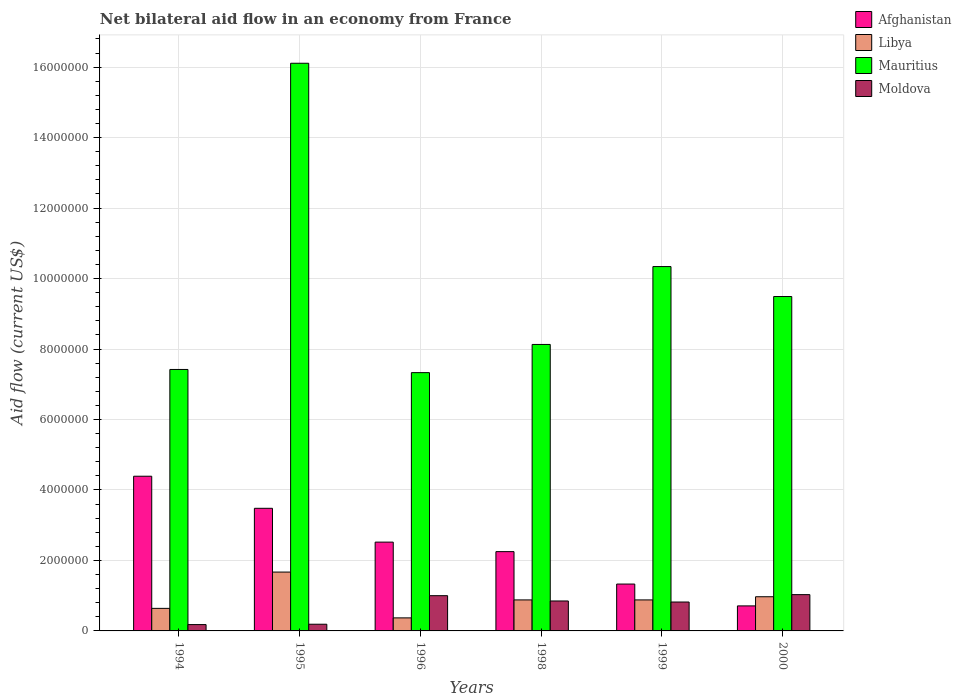How many different coloured bars are there?
Ensure brevity in your answer.  4. Are the number of bars per tick equal to the number of legend labels?
Offer a terse response. Yes. How many bars are there on the 4th tick from the left?
Your response must be concise. 4. How many bars are there on the 6th tick from the right?
Ensure brevity in your answer.  4. What is the label of the 5th group of bars from the left?
Your answer should be very brief. 1999. What is the net bilateral aid flow in Libya in 1999?
Offer a terse response. 8.80e+05. Across all years, what is the maximum net bilateral aid flow in Libya?
Your response must be concise. 1.67e+06. Across all years, what is the minimum net bilateral aid flow in Afghanistan?
Your answer should be compact. 7.10e+05. In which year was the net bilateral aid flow in Libya maximum?
Ensure brevity in your answer.  1995. What is the total net bilateral aid flow in Afghanistan in the graph?
Make the answer very short. 1.47e+07. What is the difference between the net bilateral aid flow in Libya in 1999 and that in 2000?
Provide a short and direct response. -9.00e+04. What is the difference between the net bilateral aid flow in Libya in 1999 and the net bilateral aid flow in Afghanistan in 1994?
Your response must be concise. -3.51e+06. What is the average net bilateral aid flow in Afghanistan per year?
Your response must be concise. 2.45e+06. In the year 1994, what is the difference between the net bilateral aid flow in Mauritius and net bilateral aid flow in Moldova?
Ensure brevity in your answer.  7.24e+06. What is the ratio of the net bilateral aid flow in Afghanistan in 1995 to that in 1998?
Your answer should be compact. 1.55. What is the difference between the highest and the lowest net bilateral aid flow in Moldova?
Provide a short and direct response. 8.50e+05. Is the sum of the net bilateral aid flow in Moldova in 1995 and 1998 greater than the maximum net bilateral aid flow in Mauritius across all years?
Your response must be concise. No. Is it the case that in every year, the sum of the net bilateral aid flow in Libya and net bilateral aid flow in Mauritius is greater than the sum of net bilateral aid flow in Moldova and net bilateral aid flow in Afghanistan?
Offer a very short reply. Yes. What does the 1st bar from the left in 1995 represents?
Make the answer very short. Afghanistan. What does the 4th bar from the right in 1996 represents?
Offer a terse response. Afghanistan. Are all the bars in the graph horizontal?
Offer a very short reply. No. How many years are there in the graph?
Give a very brief answer. 6. What is the difference between two consecutive major ticks on the Y-axis?
Provide a short and direct response. 2.00e+06. Are the values on the major ticks of Y-axis written in scientific E-notation?
Your answer should be compact. No. Does the graph contain any zero values?
Keep it short and to the point. No. Does the graph contain grids?
Your answer should be compact. Yes. Where does the legend appear in the graph?
Offer a terse response. Top right. How are the legend labels stacked?
Provide a short and direct response. Vertical. What is the title of the graph?
Keep it short and to the point. Net bilateral aid flow in an economy from France. What is the Aid flow (current US$) of Afghanistan in 1994?
Make the answer very short. 4.39e+06. What is the Aid flow (current US$) in Libya in 1994?
Your answer should be compact. 6.40e+05. What is the Aid flow (current US$) of Mauritius in 1994?
Your response must be concise. 7.42e+06. What is the Aid flow (current US$) in Moldova in 1994?
Provide a short and direct response. 1.80e+05. What is the Aid flow (current US$) in Afghanistan in 1995?
Your answer should be very brief. 3.48e+06. What is the Aid flow (current US$) in Libya in 1995?
Your response must be concise. 1.67e+06. What is the Aid flow (current US$) in Mauritius in 1995?
Your response must be concise. 1.61e+07. What is the Aid flow (current US$) of Moldova in 1995?
Ensure brevity in your answer.  1.90e+05. What is the Aid flow (current US$) of Afghanistan in 1996?
Give a very brief answer. 2.52e+06. What is the Aid flow (current US$) in Libya in 1996?
Give a very brief answer. 3.70e+05. What is the Aid flow (current US$) in Mauritius in 1996?
Ensure brevity in your answer.  7.33e+06. What is the Aid flow (current US$) in Afghanistan in 1998?
Provide a succinct answer. 2.25e+06. What is the Aid flow (current US$) in Libya in 1998?
Your answer should be very brief. 8.80e+05. What is the Aid flow (current US$) in Mauritius in 1998?
Your response must be concise. 8.13e+06. What is the Aid flow (current US$) of Moldova in 1998?
Give a very brief answer. 8.50e+05. What is the Aid flow (current US$) of Afghanistan in 1999?
Keep it short and to the point. 1.33e+06. What is the Aid flow (current US$) in Libya in 1999?
Your answer should be compact. 8.80e+05. What is the Aid flow (current US$) of Mauritius in 1999?
Offer a very short reply. 1.03e+07. What is the Aid flow (current US$) in Moldova in 1999?
Provide a short and direct response. 8.20e+05. What is the Aid flow (current US$) of Afghanistan in 2000?
Keep it short and to the point. 7.10e+05. What is the Aid flow (current US$) in Libya in 2000?
Ensure brevity in your answer.  9.70e+05. What is the Aid flow (current US$) of Mauritius in 2000?
Offer a terse response. 9.49e+06. What is the Aid flow (current US$) of Moldova in 2000?
Your response must be concise. 1.03e+06. Across all years, what is the maximum Aid flow (current US$) in Afghanistan?
Keep it short and to the point. 4.39e+06. Across all years, what is the maximum Aid flow (current US$) in Libya?
Your answer should be very brief. 1.67e+06. Across all years, what is the maximum Aid flow (current US$) of Mauritius?
Your response must be concise. 1.61e+07. Across all years, what is the maximum Aid flow (current US$) of Moldova?
Provide a short and direct response. 1.03e+06. Across all years, what is the minimum Aid flow (current US$) of Afghanistan?
Provide a short and direct response. 7.10e+05. Across all years, what is the minimum Aid flow (current US$) in Mauritius?
Give a very brief answer. 7.33e+06. Across all years, what is the minimum Aid flow (current US$) of Moldova?
Provide a succinct answer. 1.80e+05. What is the total Aid flow (current US$) of Afghanistan in the graph?
Keep it short and to the point. 1.47e+07. What is the total Aid flow (current US$) in Libya in the graph?
Give a very brief answer. 5.41e+06. What is the total Aid flow (current US$) in Mauritius in the graph?
Your answer should be very brief. 5.88e+07. What is the total Aid flow (current US$) in Moldova in the graph?
Your answer should be very brief. 4.07e+06. What is the difference between the Aid flow (current US$) in Afghanistan in 1994 and that in 1995?
Provide a succinct answer. 9.10e+05. What is the difference between the Aid flow (current US$) of Libya in 1994 and that in 1995?
Make the answer very short. -1.03e+06. What is the difference between the Aid flow (current US$) in Mauritius in 1994 and that in 1995?
Your answer should be very brief. -8.69e+06. What is the difference between the Aid flow (current US$) in Afghanistan in 1994 and that in 1996?
Offer a terse response. 1.87e+06. What is the difference between the Aid flow (current US$) of Libya in 1994 and that in 1996?
Provide a succinct answer. 2.70e+05. What is the difference between the Aid flow (current US$) in Moldova in 1994 and that in 1996?
Ensure brevity in your answer.  -8.20e+05. What is the difference between the Aid flow (current US$) in Afghanistan in 1994 and that in 1998?
Your answer should be very brief. 2.14e+06. What is the difference between the Aid flow (current US$) in Libya in 1994 and that in 1998?
Make the answer very short. -2.40e+05. What is the difference between the Aid flow (current US$) in Mauritius in 1994 and that in 1998?
Give a very brief answer. -7.10e+05. What is the difference between the Aid flow (current US$) of Moldova in 1994 and that in 1998?
Provide a short and direct response. -6.70e+05. What is the difference between the Aid flow (current US$) in Afghanistan in 1994 and that in 1999?
Your answer should be compact. 3.06e+06. What is the difference between the Aid flow (current US$) in Libya in 1994 and that in 1999?
Your answer should be very brief. -2.40e+05. What is the difference between the Aid flow (current US$) of Mauritius in 1994 and that in 1999?
Provide a short and direct response. -2.92e+06. What is the difference between the Aid flow (current US$) in Moldova in 1994 and that in 1999?
Provide a short and direct response. -6.40e+05. What is the difference between the Aid flow (current US$) in Afghanistan in 1994 and that in 2000?
Offer a very short reply. 3.68e+06. What is the difference between the Aid flow (current US$) of Libya in 1994 and that in 2000?
Your response must be concise. -3.30e+05. What is the difference between the Aid flow (current US$) in Mauritius in 1994 and that in 2000?
Your response must be concise. -2.07e+06. What is the difference between the Aid flow (current US$) in Moldova in 1994 and that in 2000?
Offer a terse response. -8.50e+05. What is the difference between the Aid flow (current US$) in Afghanistan in 1995 and that in 1996?
Your answer should be compact. 9.60e+05. What is the difference between the Aid flow (current US$) in Libya in 1995 and that in 1996?
Make the answer very short. 1.30e+06. What is the difference between the Aid flow (current US$) in Mauritius in 1995 and that in 1996?
Provide a succinct answer. 8.78e+06. What is the difference between the Aid flow (current US$) of Moldova in 1995 and that in 1996?
Keep it short and to the point. -8.10e+05. What is the difference between the Aid flow (current US$) of Afghanistan in 1995 and that in 1998?
Offer a very short reply. 1.23e+06. What is the difference between the Aid flow (current US$) in Libya in 1995 and that in 1998?
Make the answer very short. 7.90e+05. What is the difference between the Aid flow (current US$) of Mauritius in 1995 and that in 1998?
Provide a succinct answer. 7.98e+06. What is the difference between the Aid flow (current US$) of Moldova in 1995 and that in 1998?
Offer a very short reply. -6.60e+05. What is the difference between the Aid flow (current US$) in Afghanistan in 1995 and that in 1999?
Keep it short and to the point. 2.15e+06. What is the difference between the Aid flow (current US$) of Libya in 1995 and that in 1999?
Offer a very short reply. 7.90e+05. What is the difference between the Aid flow (current US$) of Mauritius in 1995 and that in 1999?
Keep it short and to the point. 5.77e+06. What is the difference between the Aid flow (current US$) of Moldova in 1995 and that in 1999?
Keep it short and to the point. -6.30e+05. What is the difference between the Aid flow (current US$) in Afghanistan in 1995 and that in 2000?
Offer a very short reply. 2.77e+06. What is the difference between the Aid flow (current US$) of Libya in 1995 and that in 2000?
Keep it short and to the point. 7.00e+05. What is the difference between the Aid flow (current US$) of Mauritius in 1995 and that in 2000?
Your answer should be compact. 6.62e+06. What is the difference between the Aid flow (current US$) in Moldova in 1995 and that in 2000?
Make the answer very short. -8.40e+05. What is the difference between the Aid flow (current US$) of Afghanistan in 1996 and that in 1998?
Keep it short and to the point. 2.70e+05. What is the difference between the Aid flow (current US$) in Libya in 1996 and that in 1998?
Your response must be concise. -5.10e+05. What is the difference between the Aid flow (current US$) of Mauritius in 1996 and that in 1998?
Keep it short and to the point. -8.00e+05. What is the difference between the Aid flow (current US$) in Moldova in 1996 and that in 1998?
Your response must be concise. 1.50e+05. What is the difference between the Aid flow (current US$) in Afghanistan in 1996 and that in 1999?
Give a very brief answer. 1.19e+06. What is the difference between the Aid flow (current US$) in Libya in 1996 and that in 1999?
Provide a short and direct response. -5.10e+05. What is the difference between the Aid flow (current US$) of Mauritius in 1996 and that in 1999?
Your response must be concise. -3.01e+06. What is the difference between the Aid flow (current US$) of Afghanistan in 1996 and that in 2000?
Provide a succinct answer. 1.81e+06. What is the difference between the Aid flow (current US$) in Libya in 1996 and that in 2000?
Your response must be concise. -6.00e+05. What is the difference between the Aid flow (current US$) in Mauritius in 1996 and that in 2000?
Offer a terse response. -2.16e+06. What is the difference between the Aid flow (current US$) in Moldova in 1996 and that in 2000?
Give a very brief answer. -3.00e+04. What is the difference between the Aid flow (current US$) in Afghanistan in 1998 and that in 1999?
Your answer should be very brief. 9.20e+05. What is the difference between the Aid flow (current US$) of Mauritius in 1998 and that in 1999?
Offer a terse response. -2.21e+06. What is the difference between the Aid flow (current US$) of Afghanistan in 1998 and that in 2000?
Make the answer very short. 1.54e+06. What is the difference between the Aid flow (current US$) of Libya in 1998 and that in 2000?
Keep it short and to the point. -9.00e+04. What is the difference between the Aid flow (current US$) in Mauritius in 1998 and that in 2000?
Make the answer very short. -1.36e+06. What is the difference between the Aid flow (current US$) of Moldova in 1998 and that in 2000?
Your answer should be compact. -1.80e+05. What is the difference between the Aid flow (current US$) of Afghanistan in 1999 and that in 2000?
Provide a succinct answer. 6.20e+05. What is the difference between the Aid flow (current US$) of Libya in 1999 and that in 2000?
Your response must be concise. -9.00e+04. What is the difference between the Aid flow (current US$) in Mauritius in 1999 and that in 2000?
Your answer should be very brief. 8.50e+05. What is the difference between the Aid flow (current US$) in Afghanistan in 1994 and the Aid flow (current US$) in Libya in 1995?
Your answer should be compact. 2.72e+06. What is the difference between the Aid flow (current US$) in Afghanistan in 1994 and the Aid flow (current US$) in Mauritius in 1995?
Provide a short and direct response. -1.17e+07. What is the difference between the Aid flow (current US$) of Afghanistan in 1994 and the Aid flow (current US$) of Moldova in 1995?
Keep it short and to the point. 4.20e+06. What is the difference between the Aid flow (current US$) in Libya in 1994 and the Aid flow (current US$) in Mauritius in 1995?
Your response must be concise. -1.55e+07. What is the difference between the Aid flow (current US$) of Libya in 1994 and the Aid flow (current US$) of Moldova in 1995?
Your response must be concise. 4.50e+05. What is the difference between the Aid flow (current US$) in Mauritius in 1994 and the Aid flow (current US$) in Moldova in 1995?
Keep it short and to the point. 7.23e+06. What is the difference between the Aid flow (current US$) in Afghanistan in 1994 and the Aid flow (current US$) in Libya in 1996?
Make the answer very short. 4.02e+06. What is the difference between the Aid flow (current US$) in Afghanistan in 1994 and the Aid flow (current US$) in Mauritius in 1996?
Ensure brevity in your answer.  -2.94e+06. What is the difference between the Aid flow (current US$) of Afghanistan in 1994 and the Aid flow (current US$) of Moldova in 1996?
Provide a succinct answer. 3.39e+06. What is the difference between the Aid flow (current US$) in Libya in 1994 and the Aid flow (current US$) in Mauritius in 1996?
Ensure brevity in your answer.  -6.69e+06. What is the difference between the Aid flow (current US$) in Libya in 1994 and the Aid flow (current US$) in Moldova in 1996?
Your answer should be very brief. -3.60e+05. What is the difference between the Aid flow (current US$) of Mauritius in 1994 and the Aid flow (current US$) of Moldova in 1996?
Provide a short and direct response. 6.42e+06. What is the difference between the Aid flow (current US$) in Afghanistan in 1994 and the Aid flow (current US$) in Libya in 1998?
Offer a terse response. 3.51e+06. What is the difference between the Aid flow (current US$) in Afghanistan in 1994 and the Aid flow (current US$) in Mauritius in 1998?
Provide a succinct answer. -3.74e+06. What is the difference between the Aid flow (current US$) in Afghanistan in 1994 and the Aid flow (current US$) in Moldova in 1998?
Offer a terse response. 3.54e+06. What is the difference between the Aid flow (current US$) in Libya in 1994 and the Aid flow (current US$) in Mauritius in 1998?
Your answer should be very brief. -7.49e+06. What is the difference between the Aid flow (current US$) of Libya in 1994 and the Aid flow (current US$) of Moldova in 1998?
Provide a succinct answer. -2.10e+05. What is the difference between the Aid flow (current US$) of Mauritius in 1994 and the Aid flow (current US$) of Moldova in 1998?
Provide a succinct answer. 6.57e+06. What is the difference between the Aid flow (current US$) of Afghanistan in 1994 and the Aid flow (current US$) of Libya in 1999?
Your answer should be compact. 3.51e+06. What is the difference between the Aid flow (current US$) in Afghanistan in 1994 and the Aid flow (current US$) in Mauritius in 1999?
Offer a terse response. -5.95e+06. What is the difference between the Aid flow (current US$) of Afghanistan in 1994 and the Aid flow (current US$) of Moldova in 1999?
Give a very brief answer. 3.57e+06. What is the difference between the Aid flow (current US$) in Libya in 1994 and the Aid flow (current US$) in Mauritius in 1999?
Your response must be concise. -9.70e+06. What is the difference between the Aid flow (current US$) of Libya in 1994 and the Aid flow (current US$) of Moldova in 1999?
Give a very brief answer. -1.80e+05. What is the difference between the Aid flow (current US$) of Mauritius in 1994 and the Aid flow (current US$) of Moldova in 1999?
Offer a terse response. 6.60e+06. What is the difference between the Aid flow (current US$) of Afghanistan in 1994 and the Aid flow (current US$) of Libya in 2000?
Your answer should be very brief. 3.42e+06. What is the difference between the Aid flow (current US$) in Afghanistan in 1994 and the Aid flow (current US$) in Mauritius in 2000?
Keep it short and to the point. -5.10e+06. What is the difference between the Aid flow (current US$) in Afghanistan in 1994 and the Aid flow (current US$) in Moldova in 2000?
Offer a very short reply. 3.36e+06. What is the difference between the Aid flow (current US$) of Libya in 1994 and the Aid flow (current US$) of Mauritius in 2000?
Your answer should be very brief. -8.85e+06. What is the difference between the Aid flow (current US$) in Libya in 1994 and the Aid flow (current US$) in Moldova in 2000?
Provide a succinct answer. -3.90e+05. What is the difference between the Aid flow (current US$) in Mauritius in 1994 and the Aid flow (current US$) in Moldova in 2000?
Provide a short and direct response. 6.39e+06. What is the difference between the Aid flow (current US$) in Afghanistan in 1995 and the Aid flow (current US$) in Libya in 1996?
Offer a very short reply. 3.11e+06. What is the difference between the Aid flow (current US$) of Afghanistan in 1995 and the Aid flow (current US$) of Mauritius in 1996?
Ensure brevity in your answer.  -3.85e+06. What is the difference between the Aid flow (current US$) in Afghanistan in 1995 and the Aid flow (current US$) in Moldova in 1996?
Offer a very short reply. 2.48e+06. What is the difference between the Aid flow (current US$) of Libya in 1995 and the Aid flow (current US$) of Mauritius in 1996?
Offer a terse response. -5.66e+06. What is the difference between the Aid flow (current US$) in Libya in 1995 and the Aid flow (current US$) in Moldova in 1996?
Keep it short and to the point. 6.70e+05. What is the difference between the Aid flow (current US$) of Mauritius in 1995 and the Aid flow (current US$) of Moldova in 1996?
Keep it short and to the point. 1.51e+07. What is the difference between the Aid flow (current US$) in Afghanistan in 1995 and the Aid flow (current US$) in Libya in 1998?
Offer a very short reply. 2.60e+06. What is the difference between the Aid flow (current US$) of Afghanistan in 1995 and the Aid flow (current US$) of Mauritius in 1998?
Your answer should be very brief. -4.65e+06. What is the difference between the Aid flow (current US$) in Afghanistan in 1995 and the Aid flow (current US$) in Moldova in 1998?
Give a very brief answer. 2.63e+06. What is the difference between the Aid flow (current US$) in Libya in 1995 and the Aid flow (current US$) in Mauritius in 1998?
Provide a succinct answer. -6.46e+06. What is the difference between the Aid flow (current US$) in Libya in 1995 and the Aid flow (current US$) in Moldova in 1998?
Provide a succinct answer. 8.20e+05. What is the difference between the Aid flow (current US$) of Mauritius in 1995 and the Aid flow (current US$) of Moldova in 1998?
Your response must be concise. 1.53e+07. What is the difference between the Aid flow (current US$) of Afghanistan in 1995 and the Aid flow (current US$) of Libya in 1999?
Make the answer very short. 2.60e+06. What is the difference between the Aid flow (current US$) in Afghanistan in 1995 and the Aid flow (current US$) in Mauritius in 1999?
Give a very brief answer. -6.86e+06. What is the difference between the Aid flow (current US$) in Afghanistan in 1995 and the Aid flow (current US$) in Moldova in 1999?
Offer a very short reply. 2.66e+06. What is the difference between the Aid flow (current US$) in Libya in 1995 and the Aid flow (current US$) in Mauritius in 1999?
Your answer should be very brief. -8.67e+06. What is the difference between the Aid flow (current US$) of Libya in 1995 and the Aid flow (current US$) of Moldova in 1999?
Your response must be concise. 8.50e+05. What is the difference between the Aid flow (current US$) of Mauritius in 1995 and the Aid flow (current US$) of Moldova in 1999?
Keep it short and to the point. 1.53e+07. What is the difference between the Aid flow (current US$) of Afghanistan in 1995 and the Aid flow (current US$) of Libya in 2000?
Offer a terse response. 2.51e+06. What is the difference between the Aid flow (current US$) of Afghanistan in 1995 and the Aid flow (current US$) of Mauritius in 2000?
Offer a terse response. -6.01e+06. What is the difference between the Aid flow (current US$) of Afghanistan in 1995 and the Aid flow (current US$) of Moldova in 2000?
Provide a short and direct response. 2.45e+06. What is the difference between the Aid flow (current US$) in Libya in 1995 and the Aid flow (current US$) in Mauritius in 2000?
Ensure brevity in your answer.  -7.82e+06. What is the difference between the Aid flow (current US$) of Libya in 1995 and the Aid flow (current US$) of Moldova in 2000?
Offer a very short reply. 6.40e+05. What is the difference between the Aid flow (current US$) of Mauritius in 1995 and the Aid flow (current US$) of Moldova in 2000?
Give a very brief answer. 1.51e+07. What is the difference between the Aid flow (current US$) in Afghanistan in 1996 and the Aid flow (current US$) in Libya in 1998?
Your answer should be very brief. 1.64e+06. What is the difference between the Aid flow (current US$) of Afghanistan in 1996 and the Aid flow (current US$) of Mauritius in 1998?
Keep it short and to the point. -5.61e+06. What is the difference between the Aid flow (current US$) of Afghanistan in 1996 and the Aid flow (current US$) of Moldova in 1998?
Ensure brevity in your answer.  1.67e+06. What is the difference between the Aid flow (current US$) of Libya in 1996 and the Aid flow (current US$) of Mauritius in 1998?
Ensure brevity in your answer.  -7.76e+06. What is the difference between the Aid flow (current US$) in Libya in 1996 and the Aid flow (current US$) in Moldova in 1998?
Offer a terse response. -4.80e+05. What is the difference between the Aid flow (current US$) of Mauritius in 1996 and the Aid flow (current US$) of Moldova in 1998?
Offer a terse response. 6.48e+06. What is the difference between the Aid flow (current US$) in Afghanistan in 1996 and the Aid flow (current US$) in Libya in 1999?
Offer a very short reply. 1.64e+06. What is the difference between the Aid flow (current US$) in Afghanistan in 1996 and the Aid flow (current US$) in Mauritius in 1999?
Make the answer very short. -7.82e+06. What is the difference between the Aid flow (current US$) in Afghanistan in 1996 and the Aid flow (current US$) in Moldova in 1999?
Ensure brevity in your answer.  1.70e+06. What is the difference between the Aid flow (current US$) of Libya in 1996 and the Aid flow (current US$) of Mauritius in 1999?
Keep it short and to the point. -9.97e+06. What is the difference between the Aid flow (current US$) in Libya in 1996 and the Aid flow (current US$) in Moldova in 1999?
Ensure brevity in your answer.  -4.50e+05. What is the difference between the Aid flow (current US$) of Mauritius in 1996 and the Aid flow (current US$) of Moldova in 1999?
Keep it short and to the point. 6.51e+06. What is the difference between the Aid flow (current US$) in Afghanistan in 1996 and the Aid flow (current US$) in Libya in 2000?
Ensure brevity in your answer.  1.55e+06. What is the difference between the Aid flow (current US$) of Afghanistan in 1996 and the Aid flow (current US$) of Mauritius in 2000?
Offer a terse response. -6.97e+06. What is the difference between the Aid flow (current US$) of Afghanistan in 1996 and the Aid flow (current US$) of Moldova in 2000?
Provide a succinct answer. 1.49e+06. What is the difference between the Aid flow (current US$) of Libya in 1996 and the Aid flow (current US$) of Mauritius in 2000?
Provide a succinct answer. -9.12e+06. What is the difference between the Aid flow (current US$) in Libya in 1996 and the Aid flow (current US$) in Moldova in 2000?
Keep it short and to the point. -6.60e+05. What is the difference between the Aid flow (current US$) of Mauritius in 1996 and the Aid flow (current US$) of Moldova in 2000?
Provide a short and direct response. 6.30e+06. What is the difference between the Aid flow (current US$) in Afghanistan in 1998 and the Aid flow (current US$) in Libya in 1999?
Your answer should be very brief. 1.37e+06. What is the difference between the Aid flow (current US$) of Afghanistan in 1998 and the Aid flow (current US$) of Mauritius in 1999?
Offer a very short reply. -8.09e+06. What is the difference between the Aid flow (current US$) of Afghanistan in 1998 and the Aid flow (current US$) of Moldova in 1999?
Provide a short and direct response. 1.43e+06. What is the difference between the Aid flow (current US$) in Libya in 1998 and the Aid flow (current US$) in Mauritius in 1999?
Provide a short and direct response. -9.46e+06. What is the difference between the Aid flow (current US$) of Libya in 1998 and the Aid flow (current US$) of Moldova in 1999?
Make the answer very short. 6.00e+04. What is the difference between the Aid flow (current US$) in Mauritius in 1998 and the Aid flow (current US$) in Moldova in 1999?
Your response must be concise. 7.31e+06. What is the difference between the Aid flow (current US$) of Afghanistan in 1998 and the Aid flow (current US$) of Libya in 2000?
Ensure brevity in your answer.  1.28e+06. What is the difference between the Aid flow (current US$) in Afghanistan in 1998 and the Aid flow (current US$) in Mauritius in 2000?
Offer a terse response. -7.24e+06. What is the difference between the Aid flow (current US$) in Afghanistan in 1998 and the Aid flow (current US$) in Moldova in 2000?
Provide a short and direct response. 1.22e+06. What is the difference between the Aid flow (current US$) of Libya in 1998 and the Aid flow (current US$) of Mauritius in 2000?
Give a very brief answer. -8.61e+06. What is the difference between the Aid flow (current US$) in Libya in 1998 and the Aid flow (current US$) in Moldova in 2000?
Provide a short and direct response. -1.50e+05. What is the difference between the Aid flow (current US$) of Mauritius in 1998 and the Aid flow (current US$) of Moldova in 2000?
Give a very brief answer. 7.10e+06. What is the difference between the Aid flow (current US$) in Afghanistan in 1999 and the Aid flow (current US$) in Mauritius in 2000?
Keep it short and to the point. -8.16e+06. What is the difference between the Aid flow (current US$) of Afghanistan in 1999 and the Aid flow (current US$) of Moldova in 2000?
Keep it short and to the point. 3.00e+05. What is the difference between the Aid flow (current US$) in Libya in 1999 and the Aid flow (current US$) in Mauritius in 2000?
Your answer should be compact. -8.61e+06. What is the difference between the Aid flow (current US$) of Mauritius in 1999 and the Aid flow (current US$) of Moldova in 2000?
Provide a succinct answer. 9.31e+06. What is the average Aid flow (current US$) of Afghanistan per year?
Your answer should be compact. 2.45e+06. What is the average Aid flow (current US$) in Libya per year?
Your answer should be very brief. 9.02e+05. What is the average Aid flow (current US$) of Mauritius per year?
Offer a very short reply. 9.80e+06. What is the average Aid flow (current US$) in Moldova per year?
Keep it short and to the point. 6.78e+05. In the year 1994, what is the difference between the Aid flow (current US$) in Afghanistan and Aid flow (current US$) in Libya?
Provide a succinct answer. 3.75e+06. In the year 1994, what is the difference between the Aid flow (current US$) of Afghanistan and Aid flow (current US$) of Mauritius?
Your response must be concise. -3.03e+06. In the year 1994, what is the difference between the Aid flow (current US$) in Afghanistan and Aid flow (current US$) in Moldova?
Provide a succinct answer. 4.21e+06. In the year 1994, what is the difference between the Aid flow (current US$) of Libya and Aid flow (current US$) of Mauritius?
Provide a succinct answer. -6.78e+06. In the year 1994, what is the difference between the Aid flow (current US$) in Libya and Aid flow (current US$) in Moldova?
Your answer should be very brief. 4.60e+05. In the year 1994, what is the difference between the Aid flow (current US$) of Mauritius and Aid flow (current US$) of Moldova?
Make the answer very short. 7.24e+06. In the year 1995, what is the difference between the Aid flow (current US$) of Afghanistan and Aid flow (current US$) of Libya?
Your answer should be compact. 1.81e+06. In the year 1995, what is the difference between the Aid flow (current US$) in Afghanistan and Aid flow (current US$) in Mauritius?
Offer a terse response. -1.26e+07. In the year 1995, what is the difference between the Aid flow (current US$) in Afghanistan and Aid flow (current US$) in Moldova?
Offer a very short reply. 3.29e+06. In the year 1995, what is the difference between the Aid flow (current US$) in Libya and Aid flow (current US$) in Mauritius?
Offer a very short reply. -1.44e+07. In the year 1995, what is the difference between the Aid flow (current US$) in Libya and Aid flow (current US$) in Moldova?
Offer a terse response. 1.48e+06. In the year 1995, what is the difference between the Aid flow (current US$) in Mauritius and Aid flow (current US$) in Moldova?
Offer a terse response. 1.59e+07. In the year 1996, what is the difference between the Aid flow (current US$) of Afghanistan and Aid flow (current US$) of Libya?
Give a very brief answer. 2.15e+06. In the year 1996, what is the difference between the Aid flow (current US$) in Afghanistan and Aid flow (current US$) in Mauritius?
Your answer should be very brief. -4.81e+06. In the year 1996, what is the difference between the Aid flow (current US$) in Afghanistan and Aid flow (current US$) in Moldova?
Make the answer very short. 1.52e+06. In the year 1996, what is the difference between the Aid flow (current US$) of Libya and Aid flow (current US$) of Mauritius?
Offer a very short reply. -6.96e+06. In the year 1996, what is the difference between the Aid flow (current US$) of Libya and Aid flow (current US$) of Moldova?
Offer a terse response. -6.30e+05. In the year 1996, what is the difference between the Aid flow (current US$) in Mauritius and Aid flow (current US$) in Moldova?
Your answer should be very brief. 6.33e+06. In the year 1998, what is the difference between the Aid flow (current US$) in Afghanistan and Aid flow (current US$) in Libya?
Your answer should be compact. 1.37e+06. In the year 1998, what is the difference between the Aid flow (current US$) in Afghanistan and Aid flow (current US$) in Mauritius?
Your response must be concise. -5.88e+06. In the year 1998, what is the difference between the Aid flow (current US$) in Afghanistan and Aid flow (current US$) in Moldova?
Your response must be concise. 1.40e+06. In the year 1998, what is the difference between the Aid flow (current US$) of Libya and Aid flow (current US$) of Mauritius?
Ensure brevity in your answer.  -7.25e+06. In the year 1998, what is the difference between the Aid flow (current US$) in Libya and Aid flow (current US$) in Moldova?
Your answer should be very brief. 3.00e+04. In the year 1998, what is the difference between the Aid flow (current US$) in Mauritius and Aid flow (current US$) in Moldova?
Offer a terse response. 7.28e+06. In the year 1999, what is the difference between the Aid flow (current US$) in Afghanistan and Aid flow (current US$) in Libya?
Provide a short and direct response. 4.50e+05. In the year 1999, what is the difference between the Aid flow (current US$) of Afghanistan and Aid flow (current US$) of Mauritius?
Provide a succinct answer. -9.01e+06. In the year 1999, what is the difference between the Aid flow (current US$) of Afghanistan and Aid flow (current US$) of Moldova?
Give a very brief answer. 5.10e+05. In the year 1999, what is the difference between the Aid flow (current US$) of Libya and Aid flow (current US$) of Mauritius?
Offer a terse response. -9.46e+06. In the year 1999, what is the difference between the Aid flow (current US$) in Libya and Aid flow (current US$) in Moldova?
Make the answer very short. 6.00e+04. In the year 1999, what is the difference between the Aid flow (current US$) in Mauritius and Aid flow (current US$) in Moldova?
Provide a succinct answer. 9.52e+06. In the year 2000, what is the difference between the Aid flow (current US$) in Afghanistan and Aid flow (current US$) in Mauritius?
Keep it short and to the point. -8.78e+06. In the year 2000, what is the difference between the Aid flow (current US$) in Afghanistan and Aid flow (current US$) in Moldova?
Your response must be concise. -3.20e+05. In the year 2000, what is the difference between the Aid flow (current US$) of Libya and Aid flow (current US$) of Mauritius?
Offer a terse response. -8.52e+06. In the year 2000, what is the difference between the Aid flow (current US$) of Mauritius and Aid flow (current US$) of Moldova?
Make the answer very short. 8.46e+06. What is the ratio of the Aid flow (current US$) in Afghanistan in 1994 to that in 1995?
Your response must be concise. 1.26. What is the ratio of the Aid flow (current US$) in Libya in 1994 to that in 1995?
Provide a succinct answer. 0.38. What is the ratio of the Aid flow (current US$) of Mauritius in 1994 to that in 1995?
Offer a terse response. 0.46. What is the ratio of the Aid flow (current US$) in Afghanistan in 1994 to that in 1996?
Your answer should be compact. 1.74. What is the ratio of the Aid flow (current US$) in Libya in 1994 to that in 1996?
Provide a short and direct response. 1.73. What is the ratio of the Aid flow (current US$) in Mauritius in 1994 to that in 1996?
Give a very brief answer. 1.01. What is the ratio of the Aid flow (current US$) of Moldova in 1994 to that in 1996?
Provide a succinct answer. 0.18. What is the ratio of the Aid flow (current US$) of Afghanistan in 1994 to that in 1998?
Ensure brevity in your answer.  1.95. What is the ratio of the Aid flow (current US$) in Libya in 1994 to that in 1998?
Offer a very short reply. 0.73. What is the ratio of the Aid flow (current US$) of Mauritius in 1994 to that in 1998?
Your answer should be compact. 0.91. What is the ratio of the Aid flow (current US$) in Moldova in 1994 to that in 1998?
Your answer should be very brief. 0.21. What is the ratio of the Aid flow (current US$) of Afghanistan in 1994 to that in 1999?
Offer a very short reply. 3.3. What is the ratio of the Aid flow (current US$) of Libya in 1994 to that in 1999?
Make the answer very short. 0.73. What is the ratio of the Aid flow (current US$) in Mauritius in 1994 to that in 1999?
Your answer should be very brief. 0.72. What is the ratio of the Aid flow (current US$) in Moldova in 1994 to that in 1999?
Your answer should be very brief. 0.22. What is the ratio of the Aid flow (current US$) in Afghanistan in 1994 to that in 2000?
Keep it short and to the point. 6.18. What is the ratio of the Aid flow (current US$) in Libya in 1994 to that in 2000?
Your answer should be compact. 0.66. What is the ratio of the Aid flow (current US$) of Mauritius in 1994 to that in 2000?
Provide a succinct answer. 0.78. What is the ratio of the Aid flow (current US$) in Moldova in 1994 to that in 2000?
Keep it short and to the point. 0.17. What is the ratio of the Aid flow (current US$) of Afghanistan in 1995 to that in 1996?
Offer a terse response. 1.38. What is the ratio of the Aid flow (current US$) in Libya in 1995 to that in 1996?
Keep it short and to the point. 4.51. What is the ratio of the Aid flow (current US$) of Mauritius in 1995 to that in 1996?
Offer a very short reply. 2.2. What is the ratio of the Aid flow (current US$) in Moldova in 1995 to that in 1996?
Give a very brief answer. 0.19. What is the ratio of the Aid flow (current US$) of Afghanistan in 1995 to that in 1998?
Ensure brevity in your answer.  1.55. What is the ratio of the Aid flow (current US$) of Libya in 1995 to that in 1998?
Ensure brevity in your answer.  1.9. What is the ratio of the Aid flow (current US$) in Mauritius in 1995 to that in 1998?
Offer a terse response. 1.98. What is the ratio of the Aid flow (current US$) of Moldova in 1995 to that in 1998?
Offer a very short reply. 0.22. What is the ratio of the Aid flow (current US$) of Afghanistan in 1995 to that in 1999?
Your answer should be very brief. 2.62. What is the ratio of the Aid flow (current US$) in Libya in 1995 to that in 1999?
Ensure brevity in your answer.  1.9. What is the ratio of the Aid flow (current US$) of Mauritius in 1995 to that in 1999?
Ensure brevity in your answer.  1.56. What is the ratio of the Aid flow (current US$) of Moldova in 1995 to that in 1999?
Provide a short and direct response. 0.23. What is the ratio of the Aid flow (current US$) of Afghanistan in 1995 to that in 2000?
Give a very brief answer. 4.9. What is the ratio of the Aid flow (current US$) of Libya in 1995 to that in 2000?
Keep it short and to the point. 1.72. What is the ratio of the Aid flow (current US$) of Mauritius in 1995 to that in 2000?
Ensure brevity in your answer.  1.7. What is the ratio of the Aid flow (current US$) in Moldova in 1995 to that in 2000?
Provide a short and direct response. 0.18. What is the ratio of the Aid flow (current US$) of Afghanistan in 1996 to that in 1998?
Your answer should be compact. 1.12. What is the ratio of the Aid flow (current US$) in Libya in 1996 to that in 1998?
Your answer should be compact. 0.42. What is the ratio of the Aid flow (current US$) in Mauritius in 1996 to that in 1998?
Provide a succinct answer. 0.9. What is the ratio of the Aid flow (current US$) of Moldova in 1996 to that in 1998?
Ensure brevity in your answer.  1.18. What is the ratio of the Aid flow (current US$) in Afghanistan in 1996 to that in 1999?
Your response must be concise. 1.89. What is the ratio of the Aid flow (current US$) in Libya in 1996 to that in 1999?
Ensure brevity in your answer.  0.42. What is the ratio of the Aid flow (current US$) in Mauritius in 1996 to that in 1999?
Make the answer very short. 0.71. What is the ratio of the Aid flow (current US$) of Moldova in 1996 to that in 1999?
Provide a short and direct response. 1.22. What is the ratio of the Aid flow (current US$) of Afghanistan in 1996 to that in 2000?
Offer a terse response. 3.55. What is the ratio of the Aid flow (current US$) in Libya in 1996 to that in 2000?
Your answer should be very brief. 0.38. What is the ratio of the Aid flow (current US$) in Mauritius in 1996 to that in 2000?
Your answer should be very brief. 0.77. What is the ratio of the Aid flow (current US$) of Moldova in 1996 to that in 2000?
Your answer should be very brief. 0.97. What is the ratio of the Aid flow (current US$) in Afghanistan in 1998 to that in 1999?
Your answer should be compact. 1.69. What is the ratio of the Aid flow (current US$) of Libya in 1998 to that in 1999?
Your response must be concise. 1. What is the ratio of the Aid flow (current US$) of Mauritius in 1998 to that in 1999?
Provide a succinct answer. 0.79. What is the ratio of the Aid flow (current US$) of Moldova in 1998 to that in 1999?
Make the answer very short. 1.04. What is the ratio of the Aid flow (current US$) in Afghanistan in 1998 to that in 2000?
Your answer should be compact. 3.17. What is the ratio of the Aid flow (current US$) in Libya in 1998 to that in 2000?
Ensure brevity in your answer.  0.91. What is the ratio of the Aid flow (current US$) in Mauritius in 1998 to that in 2000?
Offer a very short reply. 0.86. What is the ratio of the Aid flow (current US$) of Moldova in 1998 to that in 2000?
Provide a succinct answer. 0.83. What is the ratio of the Aid flow (current US$) of Afghanistan in 1999 to that in 2000?
Provide a succinct answer. 1.87. What is the ratio of the Aid flow (current US$) of Libya in 1999 to that in 2000?
Offer a very short reply. 0.91. What is the ratio of the Aid flow (current US$) of Mauritius in 1999 to that in 2000?
Keep it short and to the point. 1.09. What is the ratio of the Aid flow (current US$) of Moldova in 1999 to that in 2000?
Your answer should be compact. 0.8. What is the difference between the highest and the second highest Aid flow (current US$) in Afghanistan?
Ensure brevity in your answer.  9.10e+05. What is the difference between the highest and the second highest Aid flow (current US$) in Libya?
Ensure brevity in your answer.  7.00e+05. What is the difference between the highest and the second highest Aid flow (current US$) in Mauritius?
Your answer should be very brief. 5.77e+06. What is the difference between the highest and the second highest Aid flow (current US$) of Moldova?
Your response must be concise. 3.00e+04. What is the difference between the highest and the lowest Aid flow (current US$) in Afghanistan?
Your answer should be very brief. 3.68e+06. What is the difference between the highest and the lowest Aid flow (current US$) of Libya?
Your answer should be compact. 1.30e+06. What is the difference between the highest and the lowest Aid flow (current US$) of Mauritius?
Keep it short and to the point. 8.78e+06. What is the difference between the highest and the lowest Aid flow (current US$) in Moldova?
Give a very brief answer. 8.50e+05. 